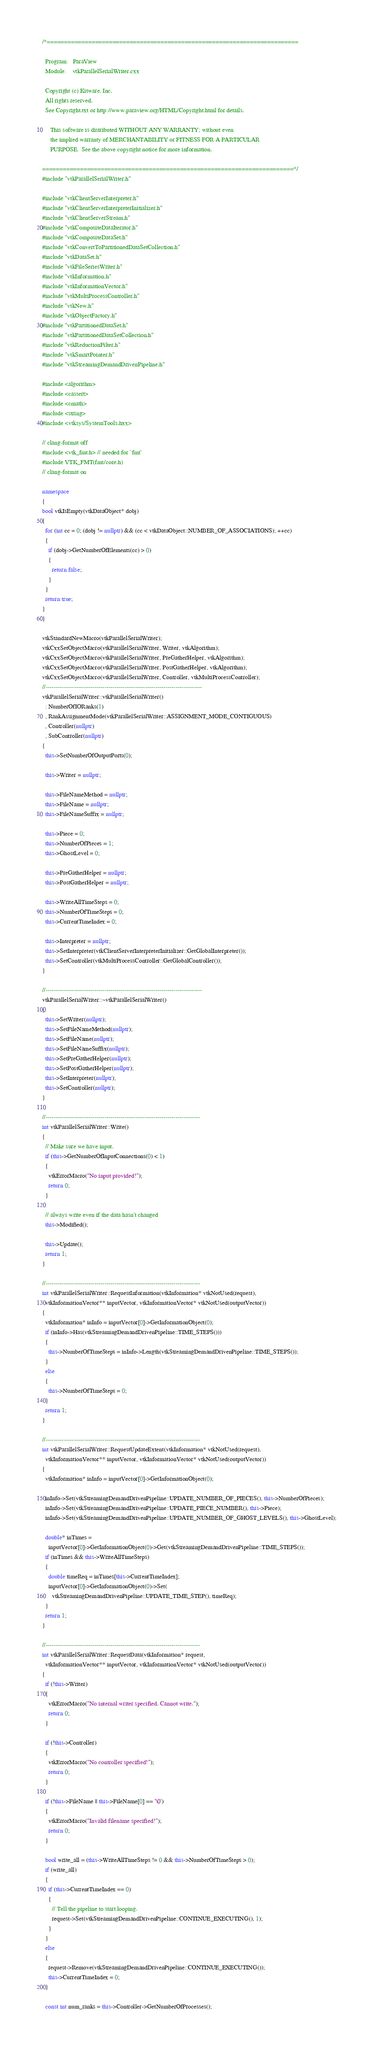<code> <loc_0><loc_0><loc_500><loc_500><_C++_>/*=========================================================================

  Program:   ParaView
  Module:    vtkParallelSerialWriter.cxx

  Copyright (c) Kitware, Inc.
  All rights reserved.
  See Copyright.txt or http://www.paraview.org/HTML/Copyright.html for details.

     This software is distributed WITHOUT ANY WARRANTY; without even
     the implied warranty of MERCHANTABILITY or FITNESS FOR A PARTICULAR
     PURPOSE.  See the above copyright notice for more information.

=========================================================================*/
#include "vtkParallelSerialWriter.h"

#include "vtkClientServerInterpreter.h"
#include "vtkClientServerInterpreterInitializer.h"
#include "vtkClientServerStream.h"
#include "vtkCompositeDataIterator.h"
#include "vtkCompositeDataSet.h"
#include "vtkConvertToPartitionedDataSetCollection.h"
#include "vtkDataSet.h"
#include "vtkFileSeriesWriter.h"
#include "vtkInformation.h"
#include "vtkInformationVector.h"
#include "vtkMultiProcessController.h"
#include "vtkNew.h"
#include "vtkObjectFactory.h"
#include "vtkPartitionedDataSet.h"
#include "vtkPartitionedDataSetCollection.h"
#include "vtkReductionFilter.h"
#include "vtkSmartPointer.h"
#include "vtkStreamingDemandDrivenPipeline.h"

#include <algorithm>
#include <cassert>
#include <cmath>
#include <string>
#include <vtksys/SystemTools.hxx>

// clang-format off
#include <vtk_fmt.h> // needed for `fmt`
#include VTK_FMT(fmt/core.h)
// clang-format on

namespace
{
bool vtkIsEmpty(vtkDataObject* dobj)
{
  for (int cc = 0; (dobj != nullptr) && (cc < vtkDataObject::NUMBER_OF_ASSOCIATIONS); ++cc)
  {
    if (dobj->GetNumberOfElements(cc) > 0)
    {
      return false;
    }
  }
  return true;
}
}

vtkStandardNewMacro(vtkParallelSerialWriter);
vtkCxxSetObjectMacro(vtkParallelSerialWriter, Writer, vtkAlgorithm);
vtkCxxSetObjectMacro(vtkParallelSerialWriter, PreGatherHelper, vtkAlgorithm);
vtkCxxSetObjectMacro(vtkParallelSerialWriter, PostGatherHelper, vtkAlgorithm);
vtkCxxSetObjectMacro(vtkParallelSerialWriter, Controller, vtkMultiProcessController);
//-----------------------------------------------------------------------------
vtkParallelSerialWriter::vtkParallelSerialWriter()
  : NumberOfIORanks(1)
  , RankAssignmentMode(vtkParallelSerialWriter::ASSIGNMENT_MODE_CONTIGUOUS)
  , Controller(nullptr)
  , SubController(nullptr)
{
  this->SetNumberOfOutputPorts(0);

  this->Writer = nullptr;

  this->FileNameMethod = nullptr;
  this->FileName = nullptr;
  this->FileNameSuffix = nullptr;

  this->Piece = 0;
  this->NumberOfPieces = 1;
  this->GhostLevel = 0;

  this->PreGatherHelper = nullptr;
  this->PostGatherHelper = nullptr;

  this->WriteAllTimeSteps = 0;
  this->NumberOfTimeSteps = 0;
  this->CurrentTimeIndex = 0;

  this->Interpreter = nullptr;
  this->SetInterpreter(vtkClientServerInterpreterInitializer::GetGlobalInterpreter());
  this->SetController(vtkMultiProcessController::GetGlobalController());
}

//-----------------------------------------------------------------------------
vtkParallelSerialWriter::~vtkParallelSerialWriter()
{
  this->SetWriter(nullptr);
  this->SetFileNameMethod(nullptr);
  this->SetFileName(nullptr);
  this->SetFileNameSuffix(nullptr);
  this->SetPreGatherHelper(nullptr);
  this->SetPostGatherHelper(nullptr);
  this->SetInterpreter(nullptr);
  this->SetController(nullptr);
}

//----------------------------------------------------------------------------
int vtkParallelSerialWriter::Write()
{
  // Make sure we have input.
  if (this->GetNumberOfInputConnections(0) < 1)
  {
    vtkErrorMacro("No input provided!");
    return 0;
  }

  // always write even if the data hasn't changed
  this->Modified();

  this->Update();
  return 1;
}

//----------------------------------------------------------------------------
int vtkParallelSerialWriter::RequestInformation(vtkInformation* vtkNotUsed(request),
  vtkInformationVector** inputVector, vtkInformationVector* vtkNotUsed(outputVector))
{
  vtkInformation* inInfo = inputVector[0]->GetInformationObject(0);
  if (inInfo->Has(vtkStreamingDemandDrivenPipeline::TIME_STEPS()))
  {
    this->NumberOfTimeSteps = inInfo->Length(vtkStreamingDemandDrivenPipeline::TIME_STEPS());
  }
  else
  {
    this->NumberOfTimeSteps = 0;
  }
  return 1;
}

//----------------------------------------------------------------------------
int vtkParallelSerialWriter::RequestUpdateExtent(vtkInformation* vtkNotUsed(request),
  vtkInformationVector** inputVector, vtkInformationVector* vtkNotUsed(outputVector))
{
  vtkInformation* inInfo = inputVector[0]->GetInformationObject(0);

  inInfo->Set(vtkStreamingDemandDrivenPipeline::UPDATE_NUMBER_OF_PIECES(), this->NumberOfPieces);
  inInfo->Set(vtkStreamingDemandDrivenPipeline::UPDATE_PIECE_NUMBER(), this->Piece);
  inInfo->Set(vtkStreamingDemandDrivenPipeline::UPDATE_NUMBER_OF_GHOST_LEVELS(), this->GhostLevel);

  double* inTimes =
    inputVector[0]->GetInformationObject(0)->Get(vtkStreamingDemandDrivenPipeline::TIME_STEPS());
  if (inTimes && this->WriteAllTimeSteps)
  {
    double timeReq = inTimes[this->CurrentTimeIndex];
    inputVector[0]->GetInformationObject(0)->Set(
      vtkStreamingDemandDrivenPipeline::UPDATE_TIME_STEP(), timeReq);
  }
  return 1;
}

//----------------------------------------------------------------------------
int vtkParallelSerialWriter::RequestData(vtkInformation* request,
  vtkInformationVector** inputVector, vtkInformationVector* vtkNotUsed(outputVector))
{
  if (!this->Writer)
  {
    vtkErrorMacro("No internal writer specified. Cannot write.");
    return 0;
  }

  if (!this->Controller)
  {
    vtkErrorMacro("No controller specified!");
    return 0;
  }

  if (!this->FileName || this->FileName[0] == '\0')
  {
    vtkErrorMacro("Invalid filename specified!");
    return 0;
  }

  bool write_all = (this->WriteAllTimeSteps != 0 && this->NumberOfTimeSteps > 0);
  if (write_all)
  {
    if (this->CurrentTimeIndex == 0)
    {
      // Tell the pipeline to start looping.
      request->Set(vtkStreamingDemandDrivenPipeline::CONTINUE_EXECUTING(), 1);
    }
  }
  else
  {
    request->Remove(vtkStreamingDemandDrivenPipeline::CONTINUE_EXECUTING());
    this->CurrentTimeIndex = 0;
  }

  const int num_ranks = this->Controller->GetNumberOfProcesses();</code> 